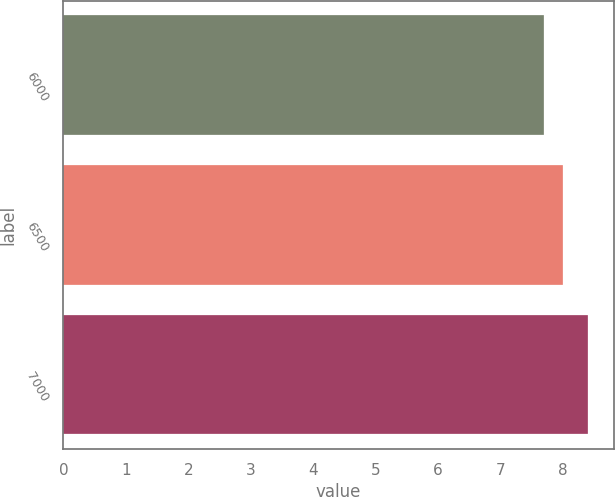Convert chart. <chart><loc_0><loc_0><loc_500><loc_500><bar_chart><fcel>6000<fcel>6500<fcel>7000<nl><fcel>7.7<fcel>8<fcel>8.4<nl></chart> 